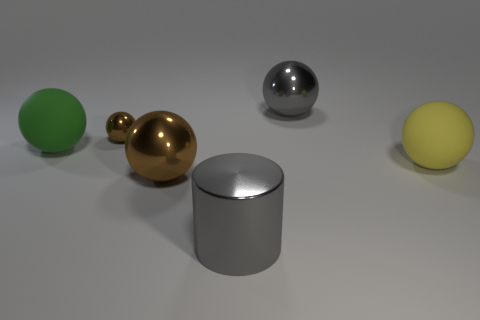The large object that is behind the yellow thing and in front of the small object has what shape?
Offer a terse response. Sphere. Does the gray metal cylinder have the same size as the matte object to the right of the cylinder?
Give a very brief answer. Yes. What is the color of the small thing that is the same shape as the large green object?
Keep it short and to the point. Brown. Do the brown shiny object that is in front of the yellow sphere and the rubber ball in front of the green thing have the same size?
Your response must be concise. Yes. Does the tiny brown metallic object have the same shape as the large yellow thing?
Your response must be concise. Yes. What number of objects are either gray shiny things behind the large brown object or metallic things?
Your answer should be compact. 4. Is there another matte thing of the same shape as the small brown thing?
Provide a short and direct response. Yes. Is the number of big spheres left of the small brown metal thing the same as the number of big gray metal balls?
Your answer should be compact. Yes. The big metallic object that is the same color as the big cylinder is what shape?
Offer a very short reply. Sphere. How many yellow spheres have the same size as the cylinder?
Offer a terse response. 1. 